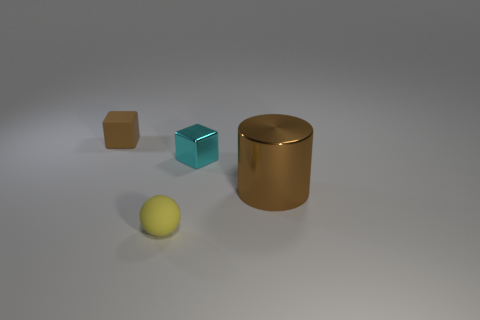How many other spheres are the same size as the yellow rubber ball?
Your answer should be compact. 0. Does the tiny thing in front of the big brown shiny cylinder have the same material as the large brown cylinder?
Provide a short and direct response. No. Is there a small purple metal cube?
Your response must be concise. No. What size is the object that is the same material as the tiny sphere?
Offer a terse response. Small. Are there any other rubber objects that have the same color as the big object?
Provide a succinct answer. Yes. There is a matte thing that is behind the big brown metallic cylinder; does it have the same color as the shiny object on the right side of the tiny cyan thing?
Your answer should be compact. Yes. What size is the other matte object that is the same color as the big object?
Your response must be concise. Small. Are there any blocks made of the same material as the small sphere?
Offer a very short reply. Yes. What is the color of the metallic cylinder?
Provide a short and direct response. Brown. How big is the brown object that is to the left of the block that is to the right of the matte thing that is behind the ball?
Provide a short and direct response. Small. 